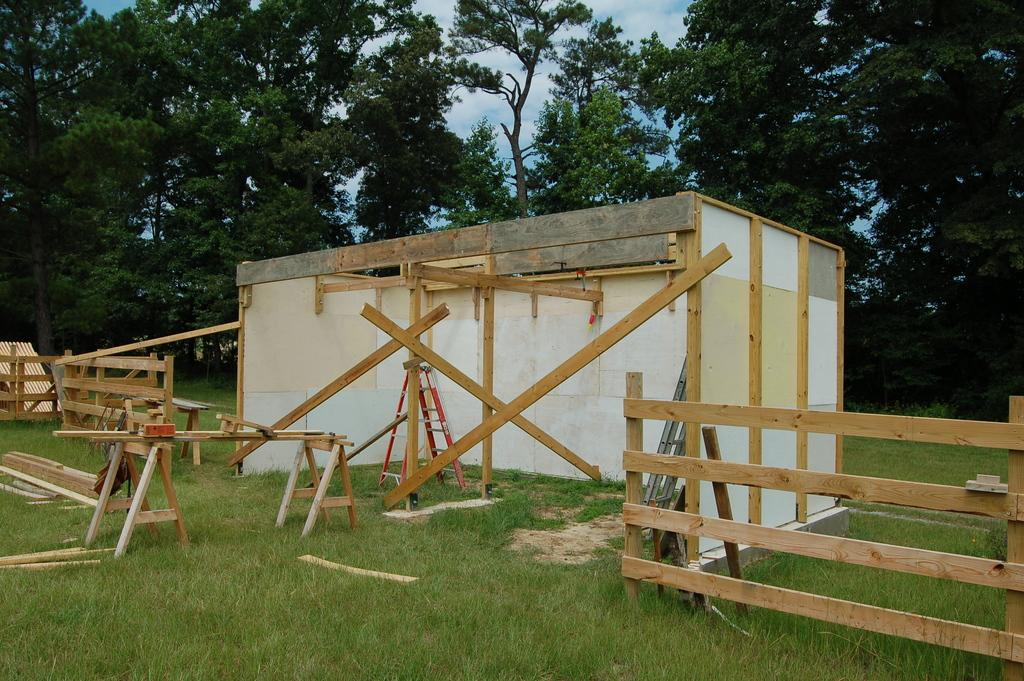What type of room is shown in the image? There is a wooden room in the image. Where is the wooden room located? The wooden room is on a grassland. What surrounds the wooden room on either side? There is a wooden fence on either side of the wooden room. What can be seen behind the wooden room? Trees are visible behind the wooden room. How many partners are visible in the image? There are no partners present in the image; it features a wooden room on a grassland with a wooden fence and trees in the background. 